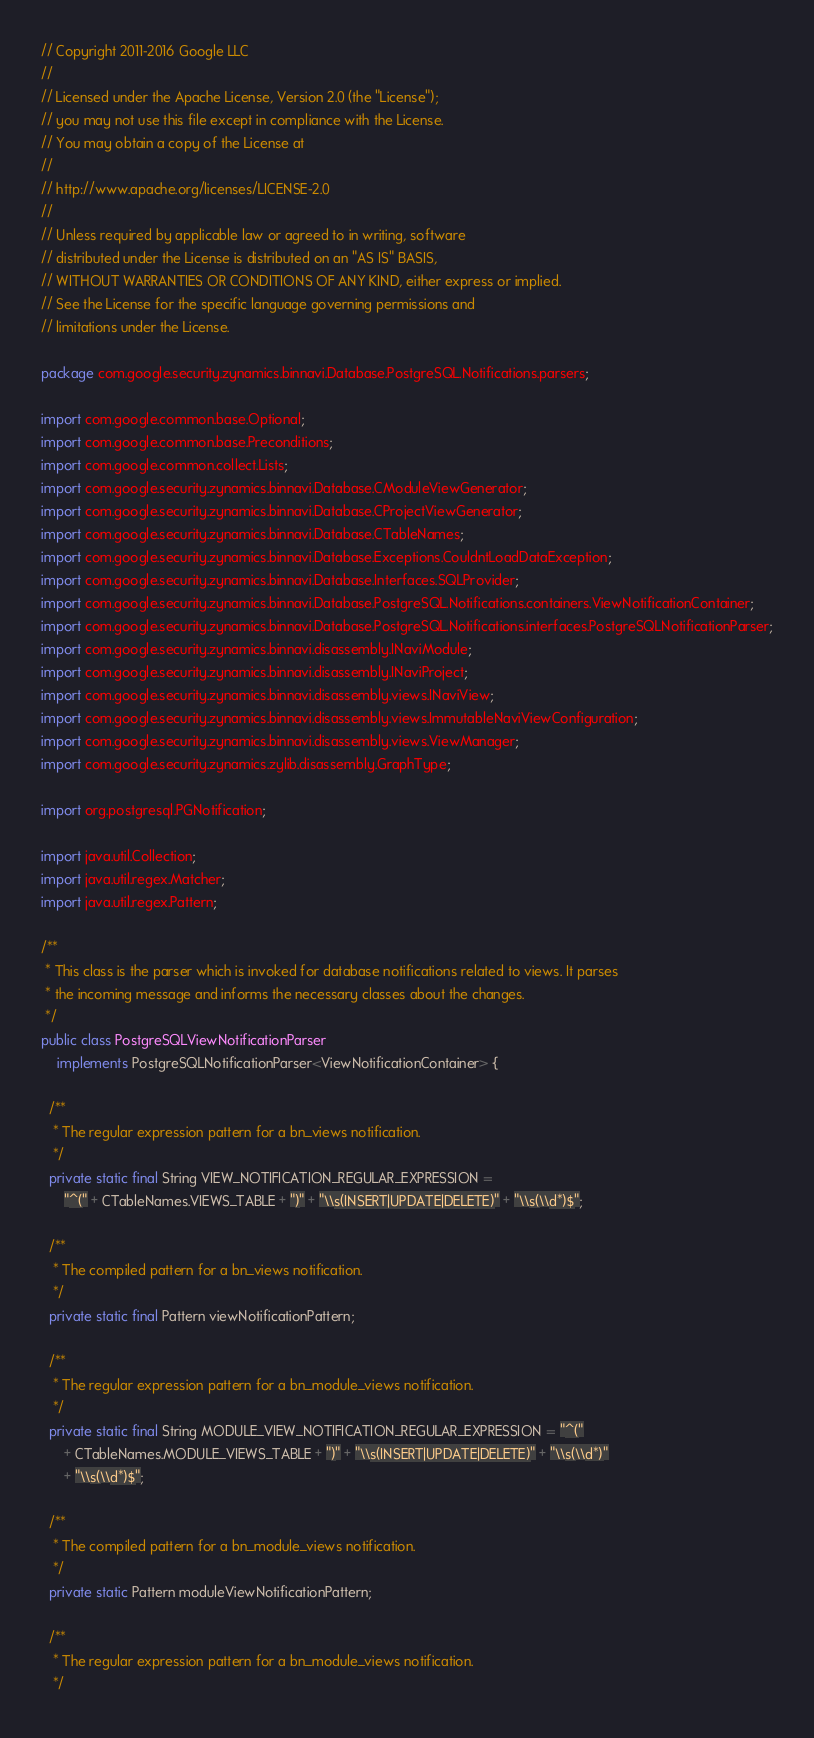Convert code to text. <code><loc_0><loc_0><loc_500><loc_500><_Java_>// Copyright 2011-2016 Google LLC
//
// Licensed under the Apache License, Version 2.0 (the "License");
// you may not use this file except in compliance with the License.
// You may obtain a copy of the License at
//
// http://www.apache.org/licenses/LICENSE-2.0
//
// Unless required by applicable law or agreed to in writing, software
// distributed under the License is distributed on an "AS IS" BASIS,
// WITHOUT WARRANTIES OR CONDITIONS OF ANY KIND, either express or implied.
// See the License for the specific language governing permissions and
// limitations under the License.

package com.google.security.zynamics.binnavi.Database.PostgreSQL.Notifications.parsers;

import com.google.common.base.Optional;
import com.google.common.base.Preconditions;
import com.google.common.collect.Lists;
import com.google.security.zynamics.binnavi.Database.CModuleViewGenerator;
import com.google.security.zynamics.binnavi.Database.CProjectViewGenerator;
import com.google.security.zynamics.binnavi.Database.CTableNames;
import com.google.security.zynamics.binnavi.Database.Exceptions.CouldntLoadDataException;
import com.google.security.zynamics.binnavi.Database.Interfaces.SQLProvider;
import com.google.security.zynamics.binnavi.Database.PostgreSQL.Notifications.containers.ViewNotificationContainer;
import com.google.security.zynamics.binnavi.Database.PostgreSQL.Notifications.interfaces.PostgreSQLNotificationParser;
import com.google.security.zynamics.binnavi.disassembly.INaviModule;
import com.google.security.zynamics.binnavi.disassembly.INaviProject;
import com.google.security.zynamics.binnavi.disassembly.views.INaviView;
import com.google.security.zynamics.binnavi.disassembly.views.ImmutableNaviViewConfiguration;
import com.google.security.zynamics.binnavi.disassembly.views.ViewManager;
import com.google.security.zynamics.zylib.disassembly.GraphType;

import org.postgresql.PGNotification;

import java.util.Collection;
import java.util.regex.Matcher;
import java.util.regex.Pattern;

/**
 * This class is the parser which is invoked for database notifications related to views. It parses
 * the incoming message and informs the necessary classes about the changes.
 */
public class PostgreSQLViewNotificationParser
    implements PostgreSQLNotificationParser<ViewNotificationContainer> {

  /**
   * The regular expression pattern for a bn_views notification.
   */
  private static final String VIEW_NOTIFICATION_REGULAR_EXPRESSION =
      "^(" + CTableNames.VIEWS_TABLE + ")" + "\\s(INSERT|UPDATE|DELETE)" + "\\s(\\d*)$";

  /**
   * The compiled pattern for a bn_views notification.
   */
  private static final Pattern viewNotificationPattern;

  /**
   * The regular expression pattern for a bn_module_views notification.
   */
  private static final String MODULE_VIEW_NOTIFICATION_REGULAR_EXPRESSION = "^("
      + CTableNames.MODULE_VIEWS_TABLE + ")" + "\\s(INSERT|UPDATE|DELETE)" + "\\s(\\d*)"
      + "\\s(\\d*)$";

  /**
   * The compiled pattern for a bn_module_views notification.
   */
  private static Pattern moduleViewNotificationPattern;

  /**
   * The regular expression pattern for a bn_module_views notification.
   */</code> 